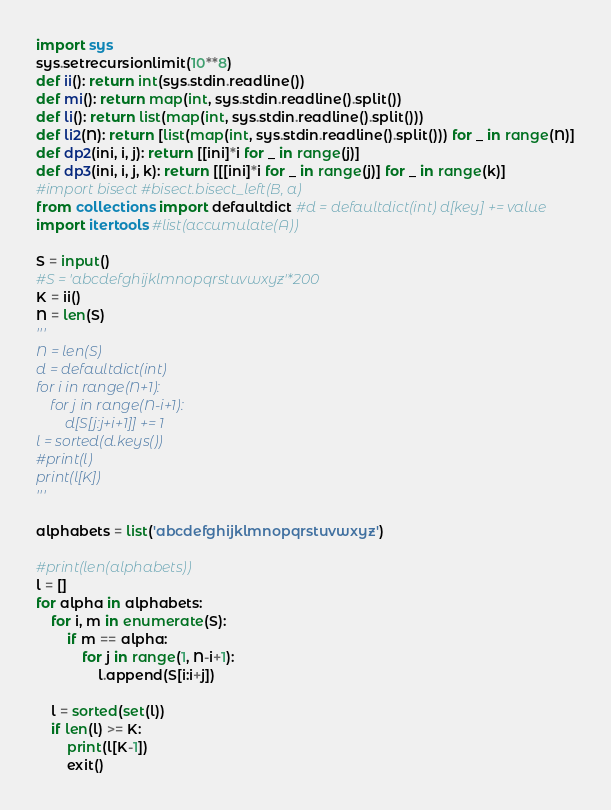Convert code to text. <code><loc_0><loc_0><loc_500><loc_500><_Python_>import sys
sys.setrecursionlimit(10**8)
def ii(): return int(sys.stdin.readline())
def mi(): return map(int, sys.stdin.readline().split())
def li(): return list(map(int, sys.stdin.readline().split()))
def li2(N): return [list(map(int, sys.stdin.readline().split())) for _ in range(N)]
def dp2(ini, i, j): return [[ini]*i for _ in range(j)]
def dp3(ini, i, j, k): return [[[ini]*i for _ in range(j)] for _ in range(k)]
#import bisect #bisect.bisect_left(B, a)
from collections import defaultdict #d = defaultdict(int) d[key] += value
import itertools #list(accumulate(A))

S = input()
#S = 'abcdefghijklmnopqrstuvwxyz'*200
K = ii()
N = len(S)
'''
N = len(S)
d = defaultdict(int)
for i in range(N+1):
    for j in range(N-i+1):
        d[S[j:j+i+1]] += 1
l = sorted(d.keys())
#print(l)
print(l[K])
'''

alphabets = list('abcdefghijklmnopqrstuvwxyz')

#print(len(alphabets))
l = []
for alpha in alphabets:
    for i, m in enumerate(S):
        if m == alpha:
            for j in range(1, N-i+1):
                l.append(S[i:i+j])

    l = sorted(set(l))
    if len(l) >= K:
        print(l[K-1])
        exit()</code> 